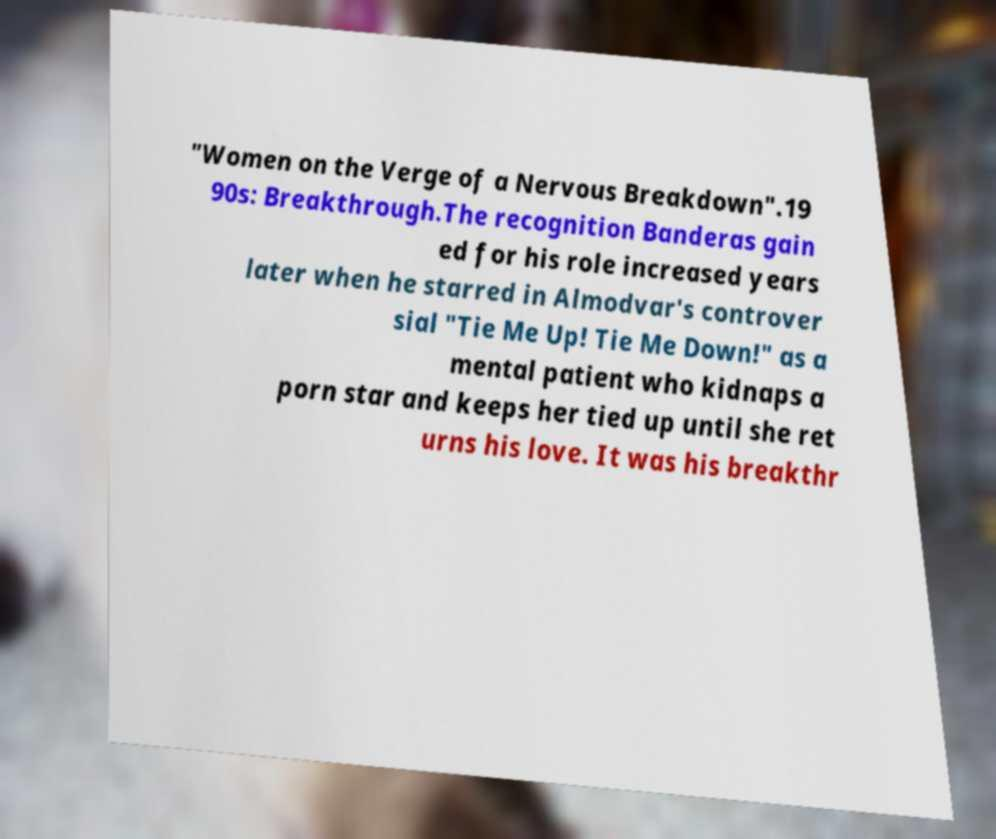Please identify and transcribe the text found in this image. "Women on the Verge of a Nervous Breakdown".19 90s: Breakthrough.The recognition Banderas gain ed for his role increased years later when he starred in Almodvar's controver sial "Tie Me Up! Tie Me Down!" as a mental patient who kidnaps a porn star and keeps her tied up until she ret urns his love. It was his breakthr 